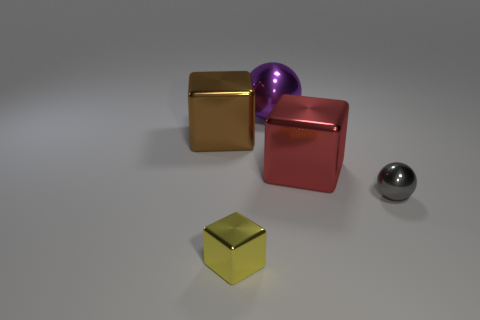Add 3 large purple shiny cylinders. How many objects exist? 8 Subtract all tiny yellow metallic blocks. How many blocks are left? 2 Subtract all cubes. How many objects are left? 2 Subtract 1 yellow blocks. How many objects are left? 4 Subtract all small yellow objects. Subtract all small shiny things. How many objects are left? 2 Add 3 large blocks. How many large blocks are left? 5 Add 5 big objects. How many big objects exist? 8 